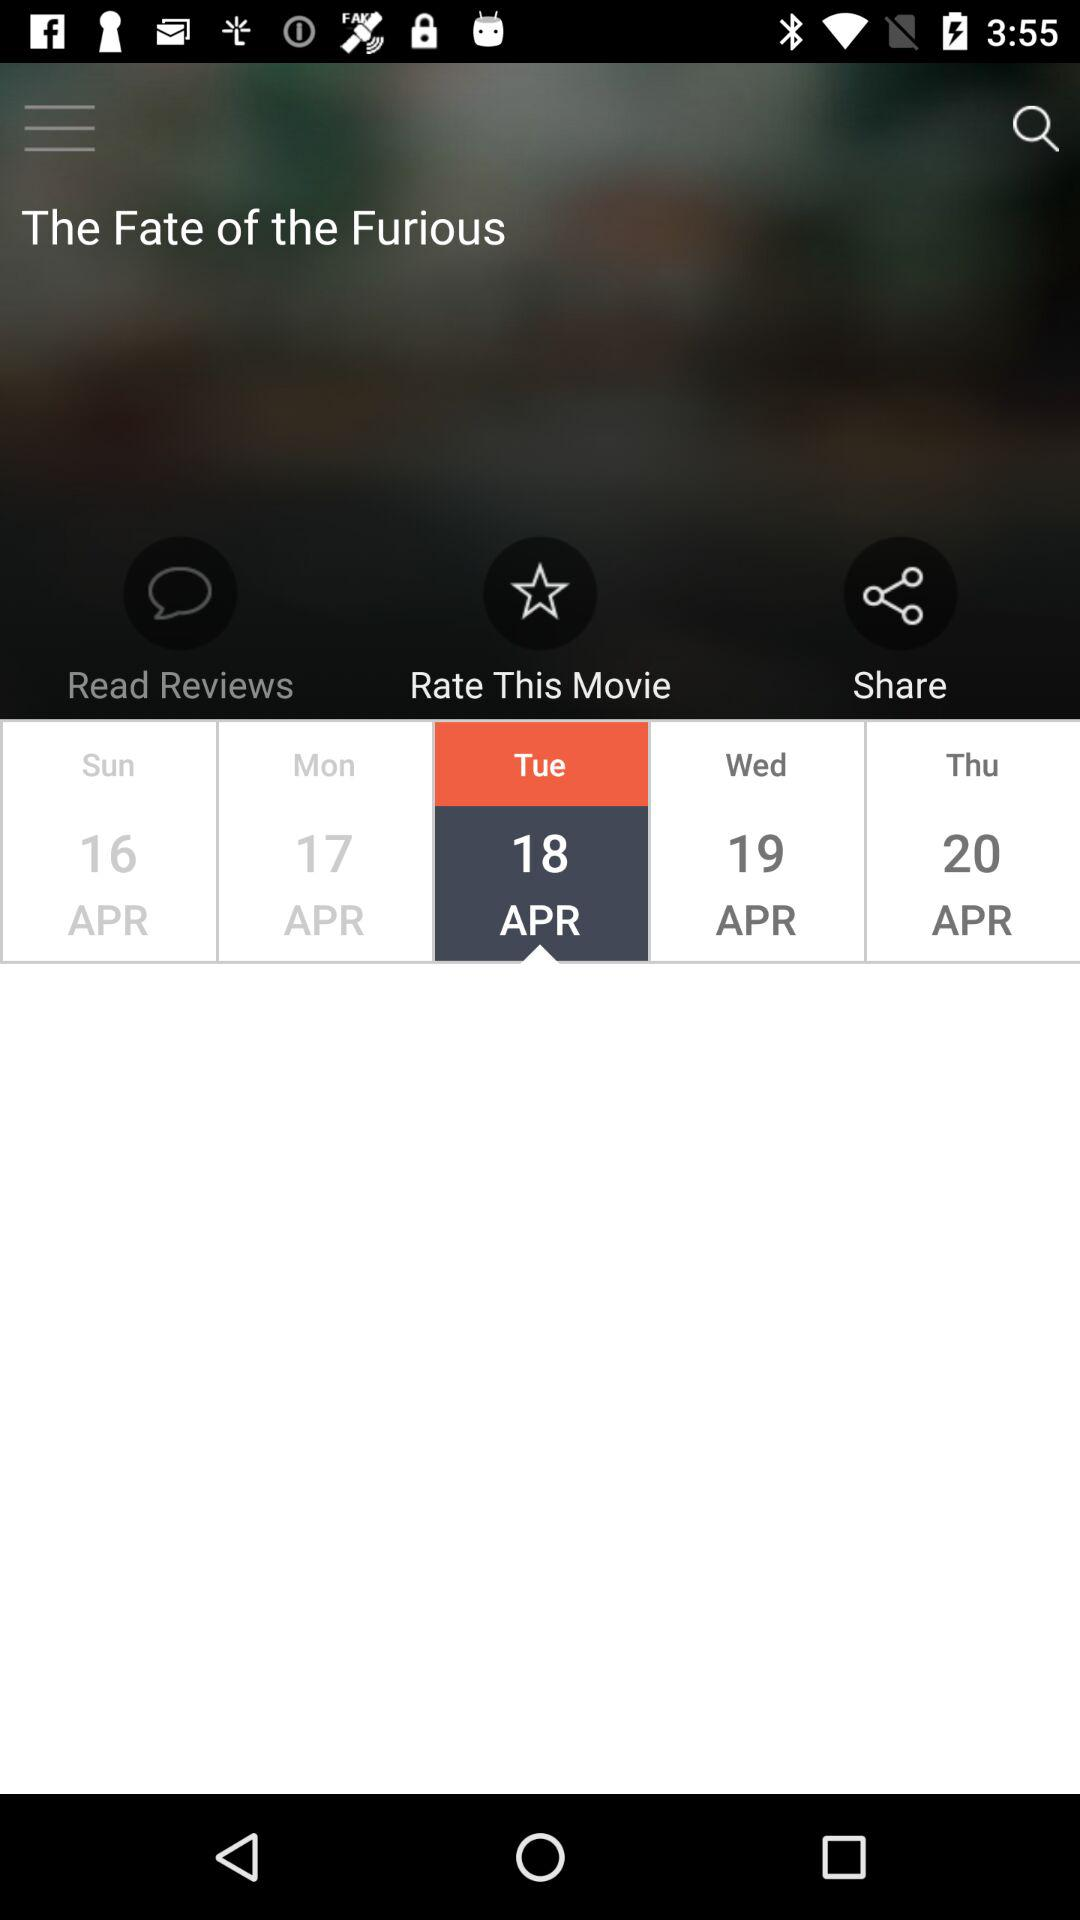What is the movie name? The movie name is "The Fate of the Furious". 